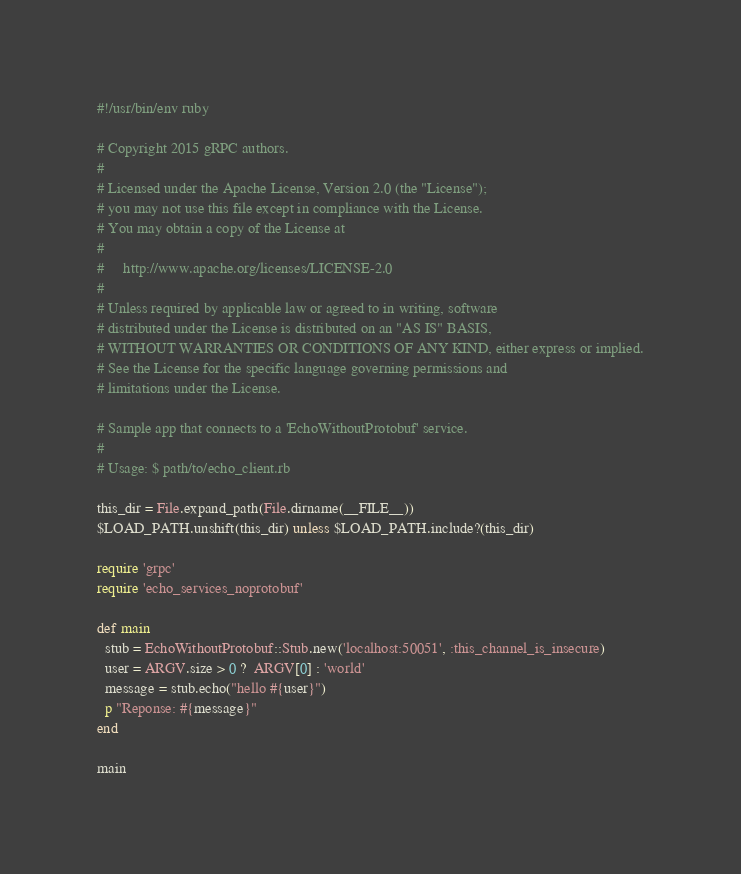Convert code to text. <code><loc_0><loc_0><loc_500><loc_500><_Ruby_>#!/usr/bin/env ruby

# Copyright 2015 gRPC authors.
#
# Licensed under the Apache License, Version 2.0 (the "License");
# you may not use this file except in compliance with the License.
# You may obtain a copy of the License at
#
#     http://www.apache.org/licenses/LICENSE-2.0
#
# Unless required by applicable law or agreed to in writing, software
# distributed under the License is distributed on an "AS IS" BASIS,
# WITHOUT WARRANTIES OR CONDITIONS OF ANY KIND, either express or implied.
# See the License for the specific language governing permissions and
# limitations under the License.

# Sample app that connects to a 'EchoWithoutProtobuf' service.
#
# Usage: $ path/to/echo_client.rb

this_dir = File.expand_path(File.dirname(__FILE__))
$LOAD_PATH.unshift(this_dir) unless $LOAD_PATH.include?(this_dir)

require 'grpc'
require 'echo_services_noprotobuf'

def main
  stub = EchoWithoutProtobuf::Stub.new('localhost:50051', :this_channel_is_insecure)
  user = ARGV.size > 0 ?  ARGV[0] : 'world'
  message = stub.echo("hello #{user}")
  p "Reponse: #{message}"
end

main
</code> 